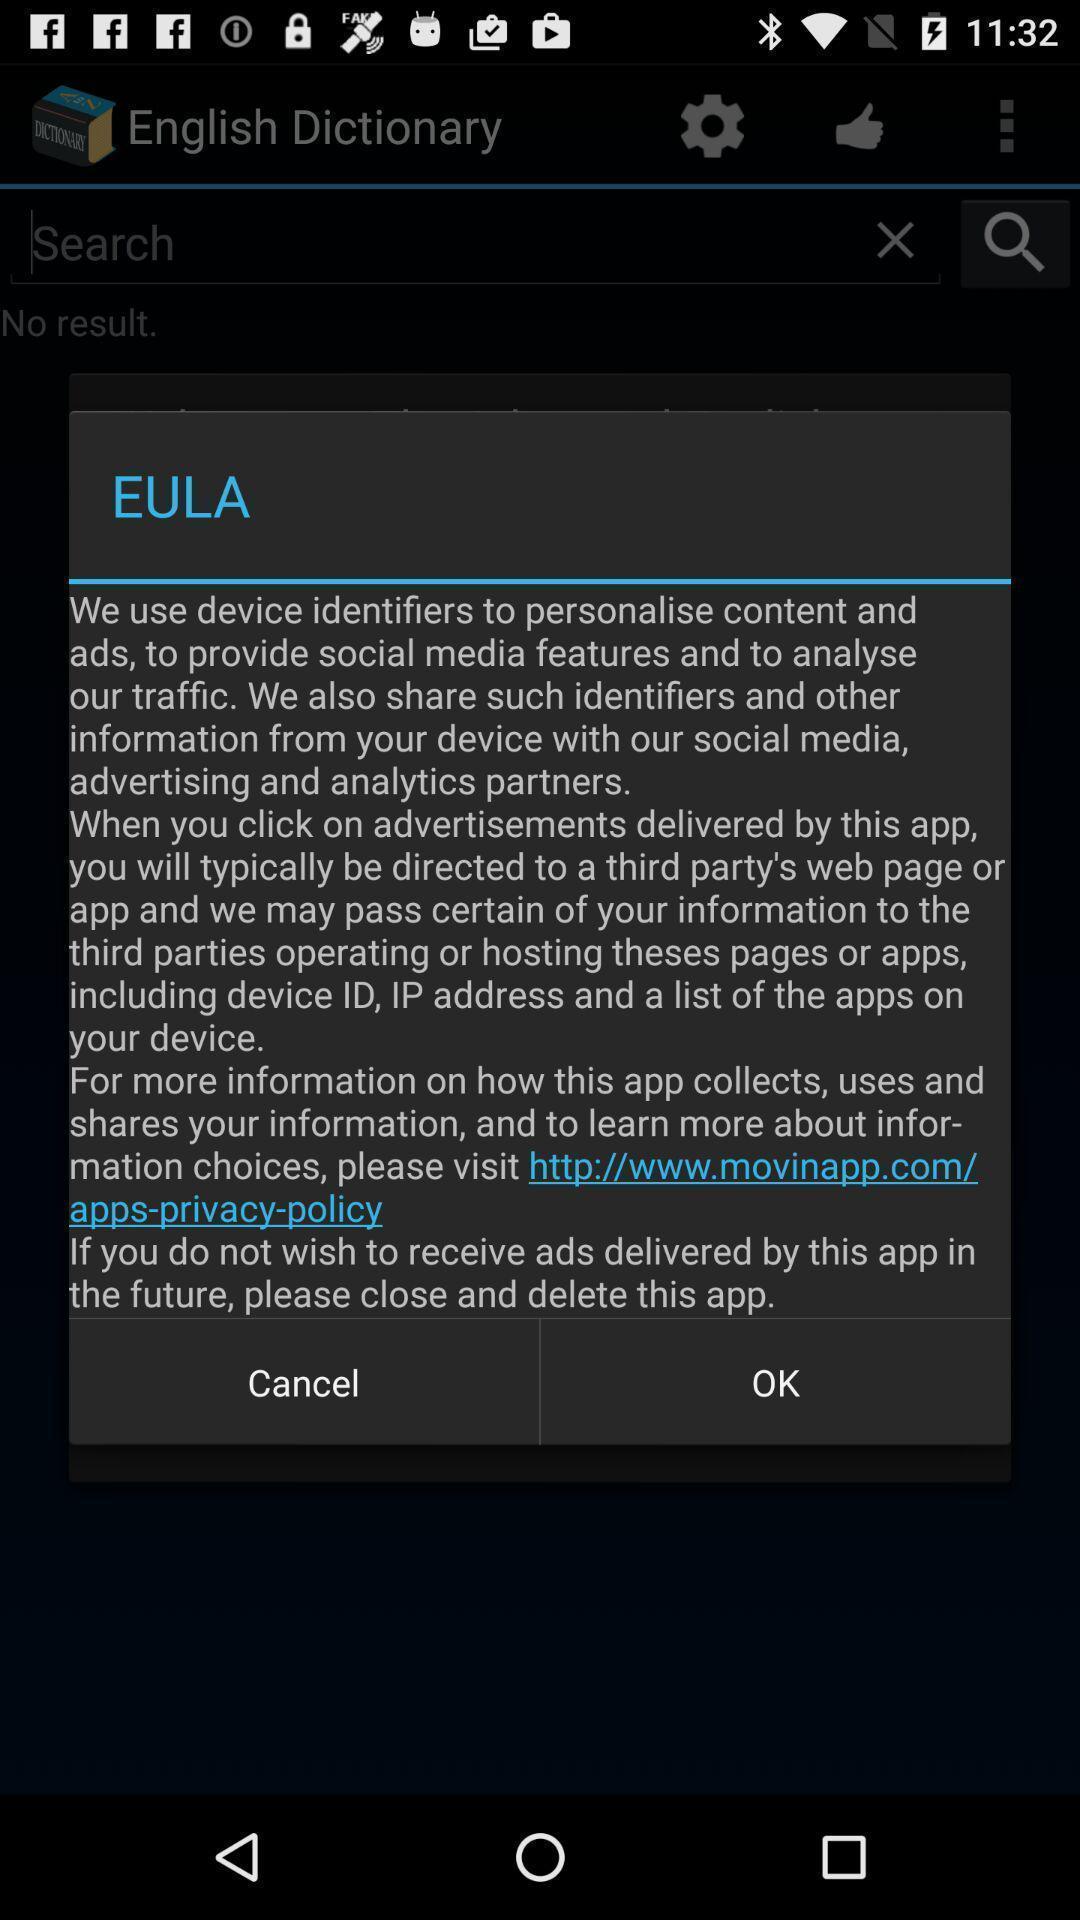Give me a summary of this screen capture. Pop-up shows eula of a learning app. 